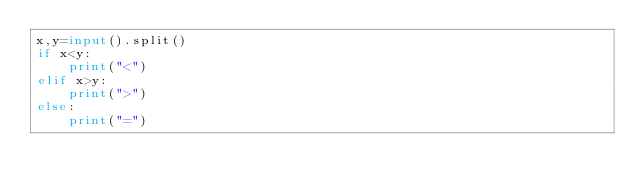Convert code to text. <code><loc_0><loc_0><loc_500><loc_500><_Python_>x,y=input().split()
if x<y:
    print("<")
elif x>y:
    print(">")
else:
    print("=")</code> 